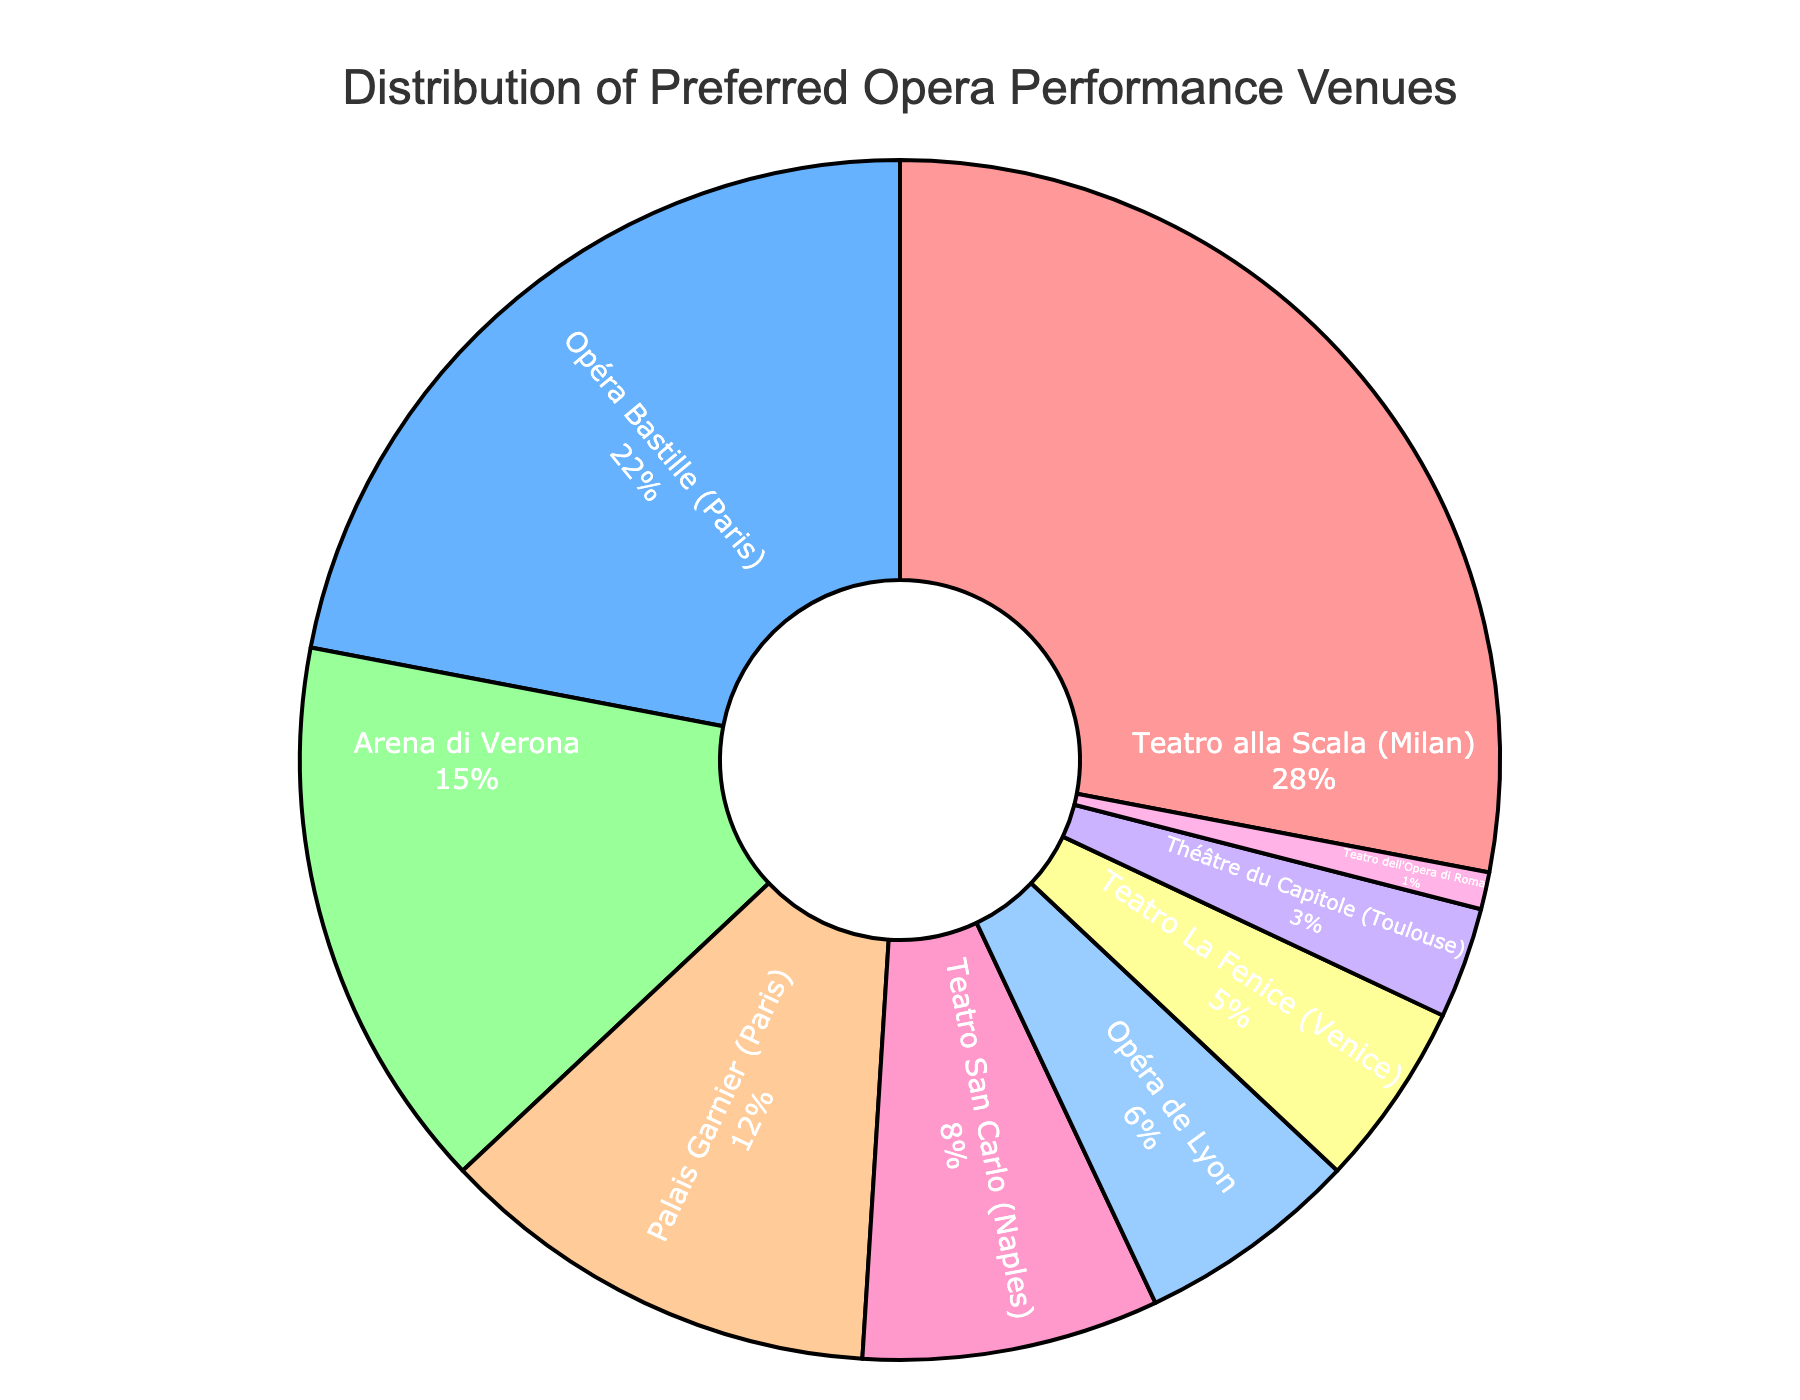Which venue has the highest percentage of preference among language learners? To determine the venue with the highest preference, look for the segment of the pie chart with the largest area. The label inside this segment will tell us the venue.
Answer: Teatro alla Scala (Milan) What is the combined percentage of preferences for the two Parisian venues? Sum the percentages of Opéra Bastille (22%) and Palais Garnier (12%) by adding 22 + 12.
Answer: 34% How much more popular is Teatro alla Scala compared to Teatro San Carlo? Subtract the percentage of Teatro San Carlo (8%) from Teatro alla Scala (28%) by calculating 28 - 8.
Answer: 20% Which venue has the smallest percentage of preference, and what is it? Identify the segment with the smallest area and read off the label and percentage inside that segment. The smallest segment is for Teatro dell'Opera di Roma.
Answer: Teatro dell'Opera di Roma, 1% What percentage of learners prefer venues in France over those in Italy? Sum the percentages of the French venues (Opéra Bastille, Palais Garnier, Opéra de Lyon, Théâtre du Capitole). Sum the Italian venues (Teatro alla Scala, Arena di Verona, Teatro San Carlo, Teatro La Fenice, Teatro dell'Opera di Roma). Compare the sums: France (22+12+6+3), Italy (28+15+8+5+1). France is 43%, Italy is 57%.
Answer: France, 43% How does the preference for Arena di Verona compare to the total preference for all French venues? Compare the percentage of Arena di Verona (15%) to the combined total for French venues (43%). Since 43 is greater than 15, French venues are more preferred.
Answer: Less If you combine the preferences for Opéra Bastille and Arena di Verona, what is their total percentage? Add the percentages of Opéra Bastille (22%) and Arena di Verona (15%), which gives us 22 + 15.
Answer: 37% What is the difference in preference percentage between the top two most preferred venues? Subtract the percentage of the second-highest venue, Opéra Bastille (22%), from the highest, Teatro alla Scala (28%), by calculating 28 - 22.
Answer: 6% Is the sum of preferences for Teatro La Fenice and Théâtre du Capitole greater than or less than that of Teatro San Carlo? Add the percentages of Teatro La Fenice (5%) and Théâtre du Capitole (3%) and compare it to Teatro San Carlo (8%). Calculate 5 + 3 = 8. Since 8 = 8, they are equal.
Answer: Equal What percentage of language learners prefer venues other than the top two? Sum the percentages of all venues except Teatro alla Scala (28%) and Opéra Bastille (22%). The sum is calculated by adding 15 + 12 + 8 + 6 + 5 + 3 + 1.
Answer: 50% 